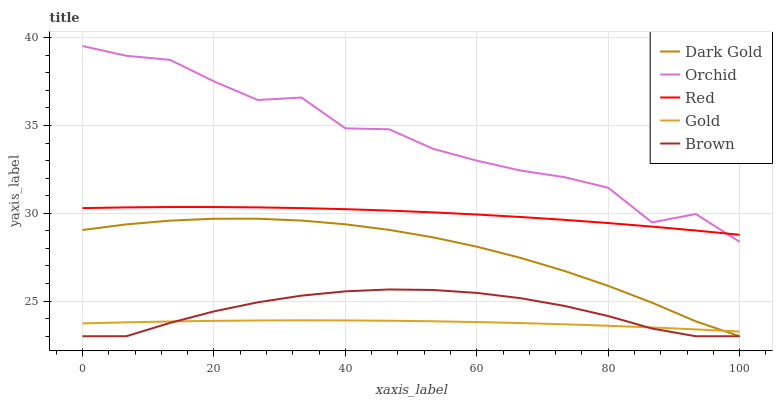Does Orchid have the minimum area under the curve?
Answer yes or no. No. Does Gold have the maximum area under the curve?
Answer yes or no. No. Is Orchid the smoothest?
Answer yes or no. No. Is Gold the roughest?
Answer yes or no. No. Does Orchid have the lowest value?
Answer yes or no. No. Does Gold have the highest value?
Answer yes or no. No. Is Dark Gold less than Orchid?
Answer yes or no. Yes. Is Orchid greater than Brown?
Answer yes or no. Yes. Does Dark Gold intersect Orchid?
Answer yes or no. No. 